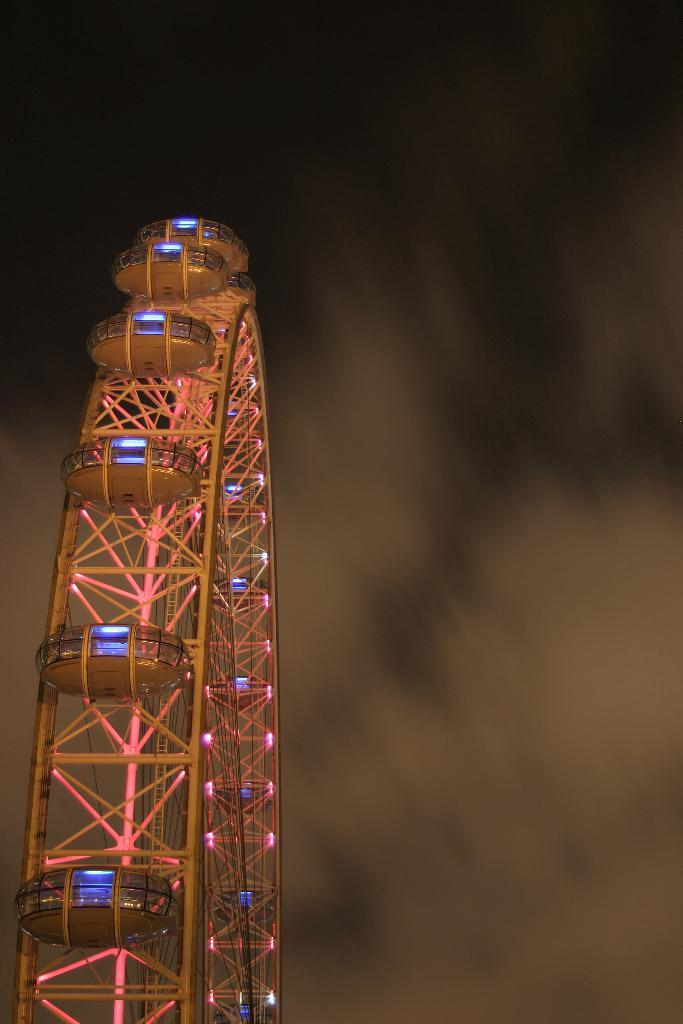What is the main subject of the image? The main subject of the image is a giant wheel. What features can be observed on the giant wheel? The giant wheel has lights and ropes. What can be seen in the background of the image? The sky is visible in the background of the image. What type of vest is the giant wheel wearing in the image? The giant wheel is not a person and therefore cannot wear a vest. 